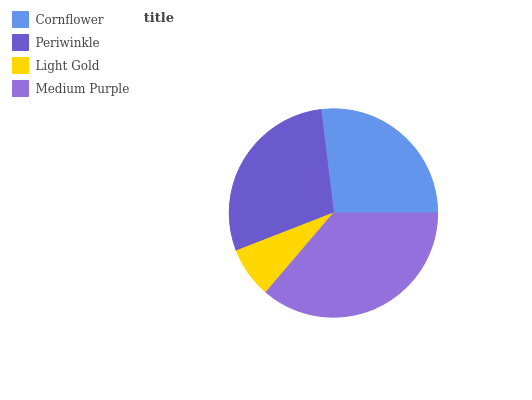Is Light Gold the minimum?
Answer yes or no. Yes. Is Medium Purple the maximum?
Answer yes or no. Yes. Is Periwinkle the minimum?
Answer yes or no. No. Is Periwinkle the maximum?
Answer yes or no. No. Is Periwinkle greater than Cornflower?
Answer yes or no. Yes. Is Cornflower less than Periwinkle?
Answer yes or no. Yes. Is Cornflower greater than Periwinkle?
Answer yes or no. No. Is Periwinkle less than Cornflower?
Answer yes or no. No. Is Periwinkle the high median?
Answer yes or no. Yes. Is Cornflower the low median?
Answer yes or no. Yes. Is Medium Purple the high median?
Answer yes or no. No. Is Medium Purple the low median?
Answer yes or no. No. 